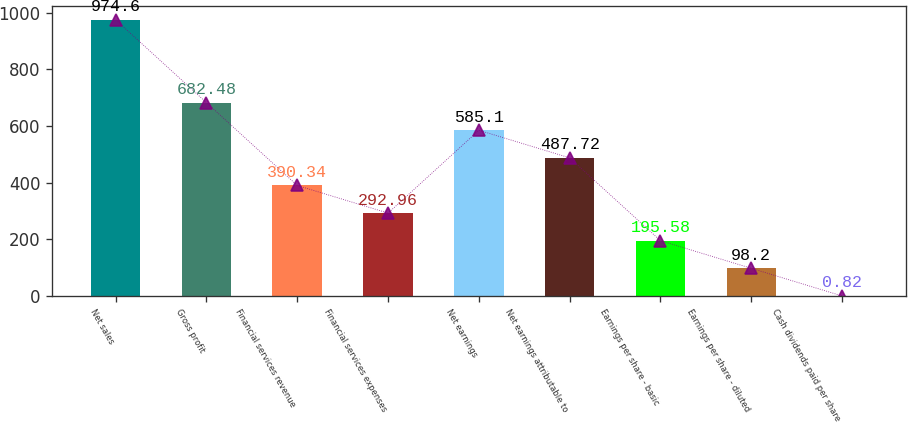Convert chart. <chart><loc_0><loc_0><loc_500><loc_500><bar_chart><fcel>Net sales<fcel>Gross profit<fcel>Financial services revenue<fcel>Financial services expenses<fcel>Net earnings<fcel>Net earnings attributable to<fcel>Earnings per share - basic<fcel>Earnings per share - diluted<fcel>Cash dividends paid per share<nl><fcel>974.6<fcel>682.48<fcel>390.34<fcel>292.96<fcel>585.1<fcel>487.72<fcel>195.58<fcel>98.2<fcel>0.82<nl></chart> 